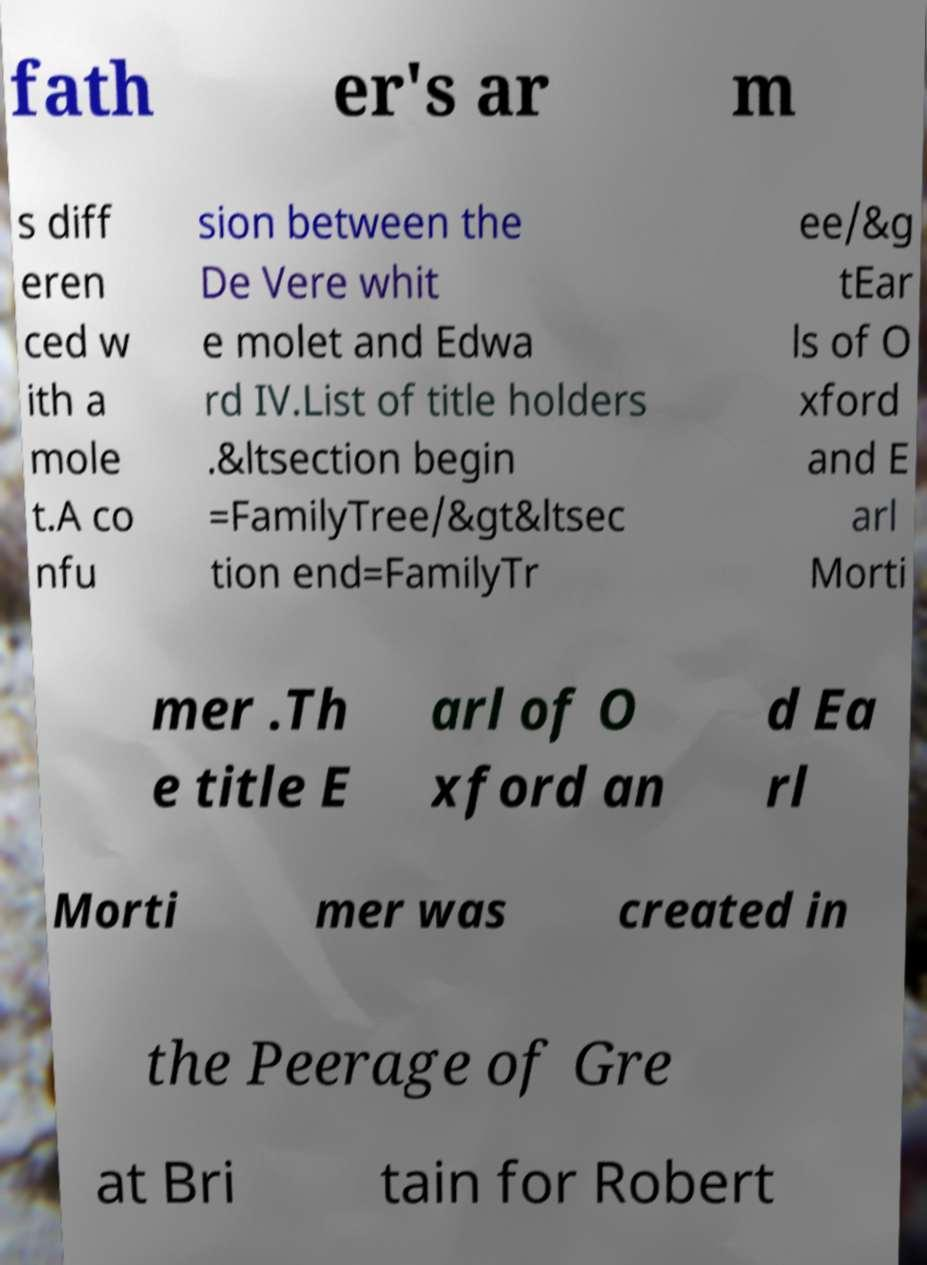Can you read and provide the text displayed in the image?This photo seems to have some interesting text. Can you extract and type it out for me? fath er's ar m s diff eren ced w ith a mole t.A co nfu sion between the De Vere whit e molet and Edwa rd IV.List of title holders .&ltsection begin =FamilyTree/&gt&ltsec tion end=FamilyTr ee/&g tEar ls of O xford and E arl Morti mer .Th e title E arl of O xford an d Ea rl Morti mer was created in the Peerage of Gre at Bri tain for Robert 